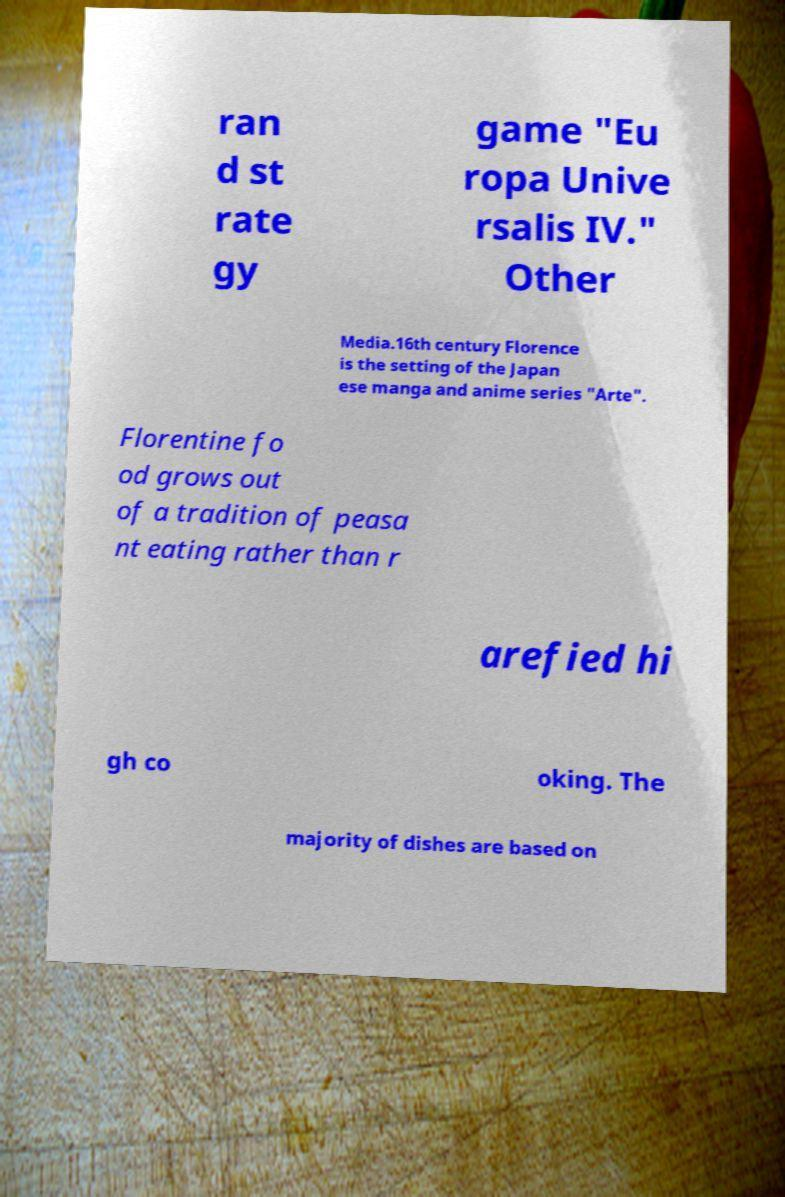Could you assist in decoding the text presented in this image and type it out clearly? ran d st rate gy game "Eu ropa Unive rsalis IV." Other Media.16th century Florence is the setting of the Japan ese manga and anime series "Arte". Florentine fo od grows out of a tradition of peasa nt eating rather than r arefied hi gh co oking. The majority of dishes are based on 